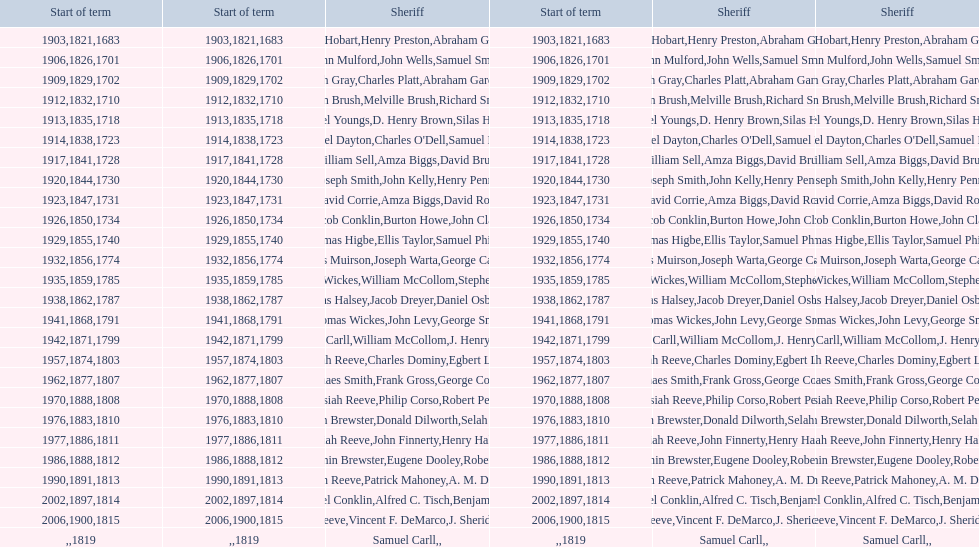Did robert petty serve before josiah reeve? No. 